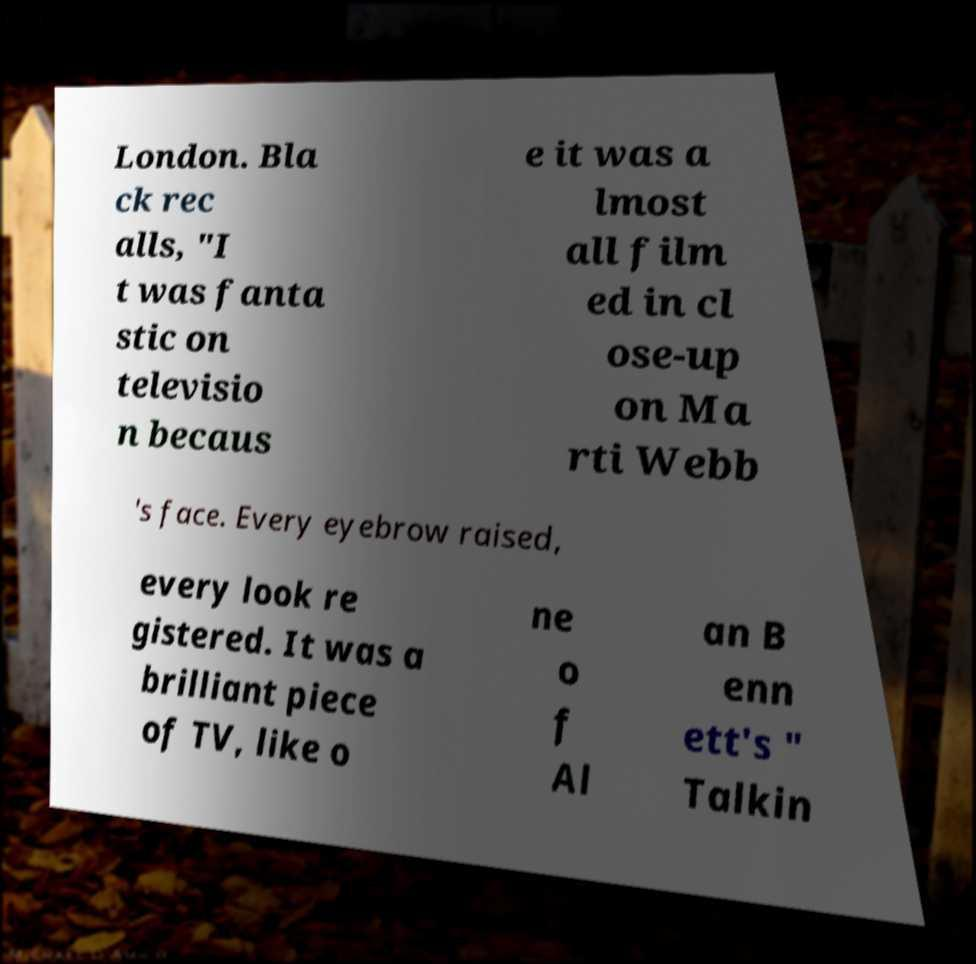Please read and relay the text visible in this image. What does it say? London. Bla ck rec alls, "I t was fanta stic on televisio n becaus e it was a lmost all film ed in cl ose-up on Ma rti Webb 's face. Every eyebrow raised, every look re gistered. It was a brilliant piece of TV, like o ne o f Al an B enn ett's " Talkin 